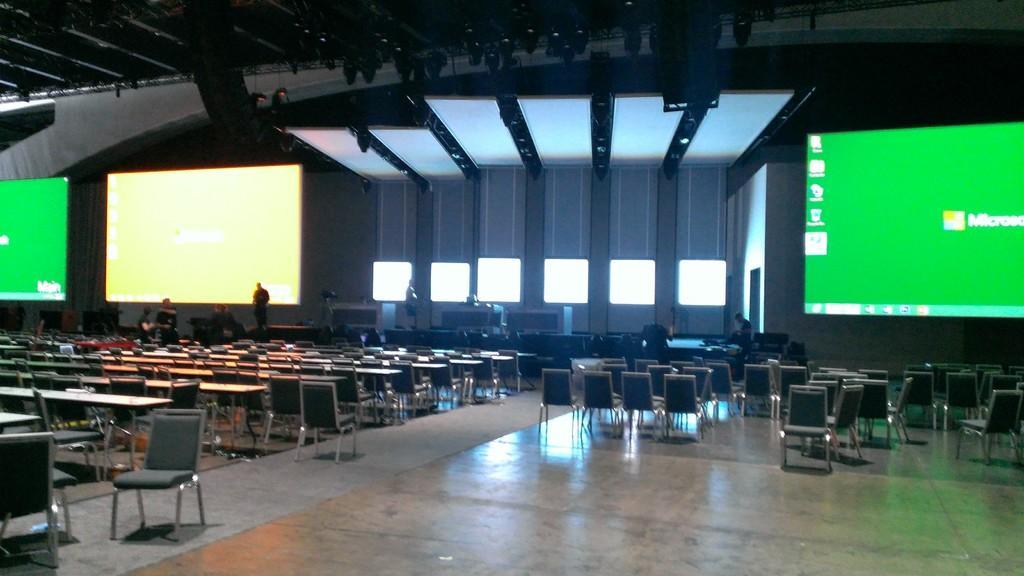How would you summarize this image in a sentence or two? In this image we can see there are screens on the top and few people standing on the stage, also there are so many chairs on the hall. 